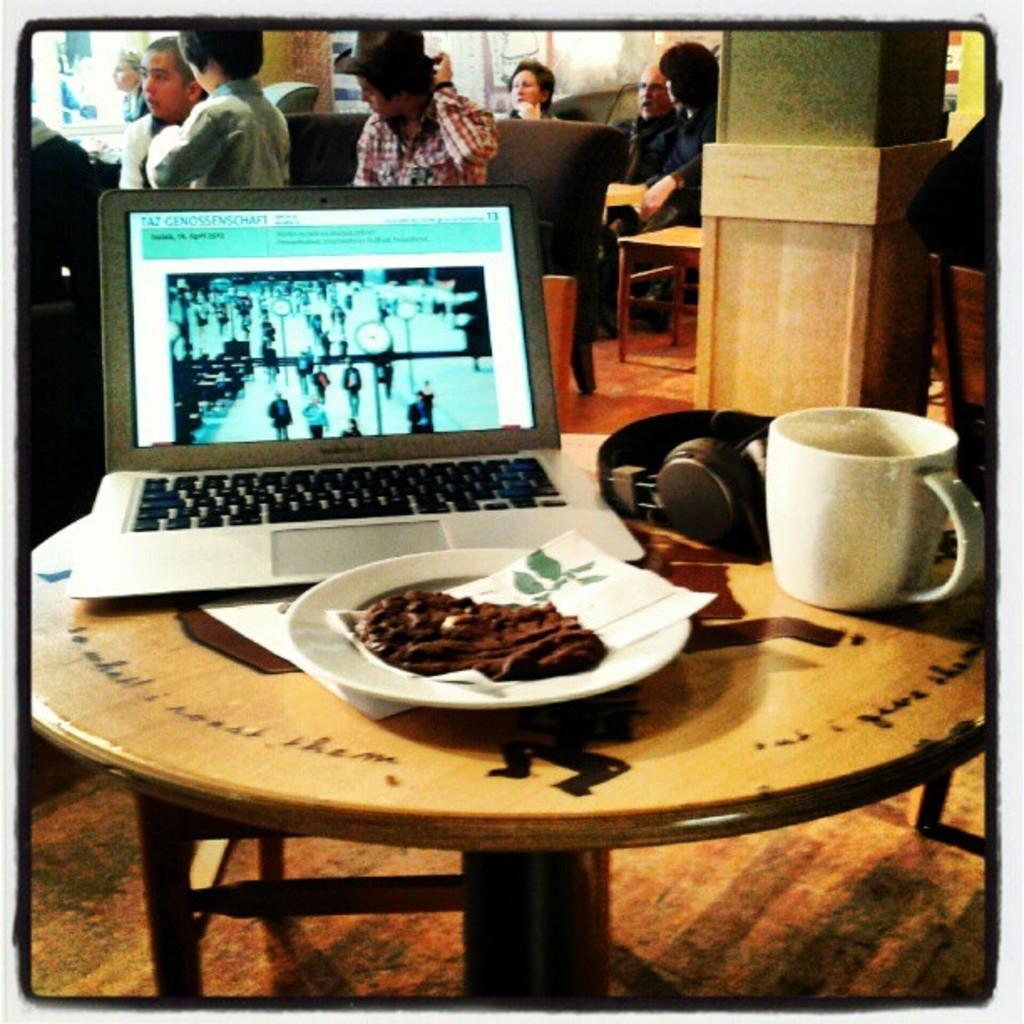Please provide a concise description of this image. This is clicked inside a room. There are tables and chairs. On the tables there is plate, tissue, cup, headphones, laptop and eatable. There are people sitting on chairs in the top. 